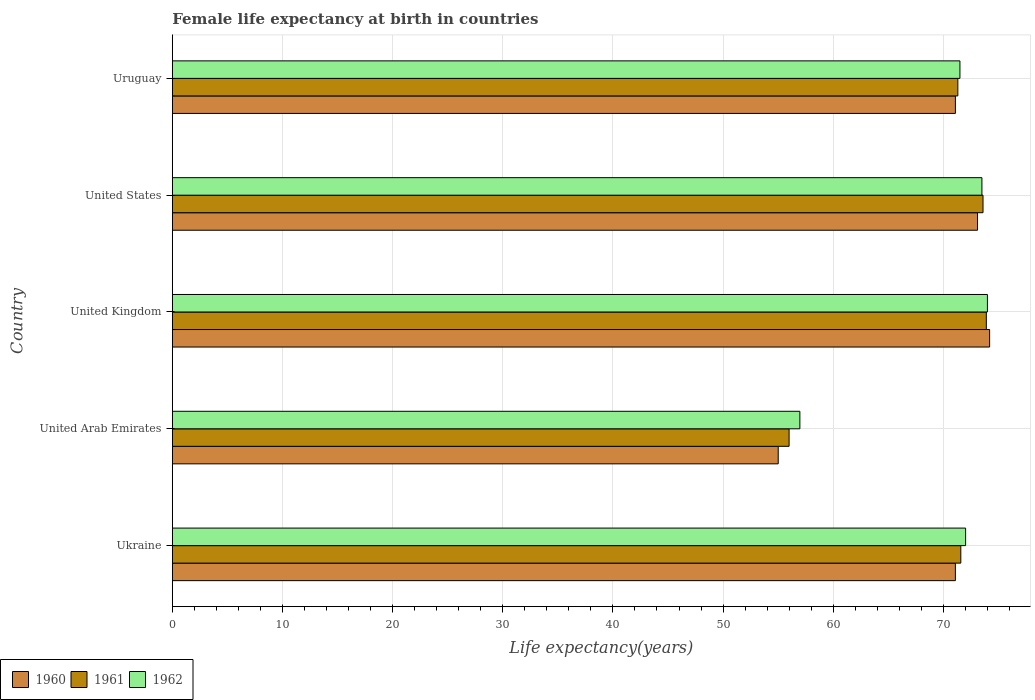How many different coloured bars are there?
Provide a succinct answer. 3. How many bars are there on the 2nd tick from the top?
Give a very brief answer. 3. How many bars are there on the 3rd tick from the bottom?
Make the answer very short. 3. What is the label of the 5th group of bars from the top?
Give a very brief answer. Ukraine. What is the female life expectancy at birth in 1962 in United States?
Keep it short and to the point. 73.5. Across all countries, what is the minimum female life expectancy at birth in 1960?
Keep it short and to the point. 55.01. In which country was the female life expectancy at birth in 1960 maximum?
Provide a short and direct response. United Kingdom. In which country was the female life expectancy at birth in 1960 minimum?
Provide a succinct answer. United Arab Emirates. What is the total female life expectancy at birth in 1960 in the graph?
Keep it short and to the point. 344.49. What is the difference between the female life expectancy at birth in 1962 in United Kingdom and the female life expectancy at birth in 1961 in Uruguay?
Your answer should be very brief. 2.69. What is the average female life expectancy at birth in 1961 per country?
Give a very brief answer. 69.28. What is the difference between the female life expectancy at birth in 1961 and female life expectancy at birth in 1960 in United Arab Emirates?
Offer a terse response. 0.99. What is the ratio of the female life expectancy at birth in 1961 in United Arab Emirates to that in United States?
Offer a terse response. 0.76. What is the difference between the highest and the lowest female life expectancy at birth in 1960?
Offer a terse response. 19.19. In how many countries, is the female life expectancy at birth in 1960 greater than the average female life expectancy at birth in 1960 taken over all countries?
Ensure brevity in your answer.  4. Is the sum of the female life expectancy at birth in 1960 in United Arab Emirates and United Kingdom greater than the maximum female life expectancy at birth in 1961 across all countries?
Make the answer very short. Yes. Are all the bars in the graph horizontal?
Make the answer very short. Yes. How many countries are there in the graph?
Offer a terse response. 5. What is the difference between two consecutive major ticks on the X-axis?
Offer a terse response. 10. What is the title of the graph?
Provide a short and direct response. Female life expectancy at birth in countries. Does "1998" appear as one of the legend labels in the graph?
Ensure brevity in your answer.  No. What is the label or title of the X-axis?
Your answer should be compact. Life expectancy(years). What is the label or title of the Y-axis?
Keep it short and to the point. Country. What is the Life expectancy(years) in 1960 in Ukraine?
Provide a succinct answer. 71.09. What is the Life expectancy(years) of 1961 in Ukraine?
Keep it short and to the point. 71.58. What is the Life expectancy(years) of 1962 in Ukraine?
Provide a succinct answer. 72.02. What is the Life expectancy(years) in 1960 in United Arab Emirates?
Your answer should be compact. 55.01. What is the Life expectancy(years) of 1961 in United Arab Emirates?
Offer a terse response. 55.99. What is the Life expectancy(years) of 1962 in United Arab Emirates?
Keep it short and to the point. 56.97. What is the Life expectancy(years) of 1960 in United Kingdom?
Provide a short and direct response. 74.2. What is the Life expectancy(years) in 1961 in United Kingdom?
Keep it short and to the point. 73.9. What is the Life expectancy(years) of 1962 in United Kingdom?
Give a very brief answer. 74. What is the Life expectancy(years) in 1960 in United States?
Make the answer very short. 73.1. What is the Life expectancy(years) in 1961 in United States?
Make the answer very short. 73.6. What is the Life expectancy(years) of 1962 in United States?
Offer a terse response. 73.5. What is the Life expectancy(years) of 1960 in Uruguay?
Offer a terse response. 71.09. What is the Life expectancy(years) of 1961 in Uruguay?
Your response must be concise. 71.31. What is the Life expectancy(years) of 1962 in Uruguay?
Your answer should be compact. 71.5. Across all countries, what is the maximum Life expectancy(years) of 1960?
Give a very brief answer. 74.2. Across all countries, what is the maximum Life expectancy(years) in 1961?
Provide a succinct answer. 73.9. Across all countries, what is the maximum Life expectancy(years) of 1962?
Provide a short and direct response. 74. Across all countries, what is the minimum Life expectancy(years) of 1960?
Keep it short and to the point. 55.01. Across all countries, what is the minimum Life expectancy(years) in 1961?
Provide a short and direct response. 55.99. Across all countries, what is the minimum Life expectancy(years) in 1962?
Your answer should be compact. 56.97. What is the total Life expectancy(years) in 1960 in the graph?
Your answer should be very brief. 344.49. What is the total Life expectancy(years) in 1961 in the graph?
Make the answer very short. 346.39. What is the total Life expectancy(years) of 1962 in the graph?
Provide a short and direct response. 348. What is the difference between the Life expectancy(years) of 1960 in Ukraine and that in United Arab Emirates?
Offer a terse response. 16.09. What is the difference between the Life expectancy(years) of 1961 in Ukraine and that in United Arab Emirates?
Ensure brevity in your answer.  15.59. What is the difference between the Life expectancy(years) in 1962 in Ukraine and that in United Arab Emirates?
Provide a short and direct response. 15.05. What is the difference between the Life expectancy(years) in 1960 in Ukraine and that in United Kingdom?
Your response must be concise. -3.11. What is the difference between the Life expectancy(years) of 1961 in Ukraine and that in United Kingdom?
Offer a terse response. -2.32. What is the difference between the Life expectancy(years) in 1962 in Ukraine and that in United Kingdom?
Offer a very short reply. -1.98. What is the difference between the Life expectancy(years) in 1960 in Ukraine and that in United States?
Your response must be concise. -2.01. What is the difference between the Life expectancy(years) in 1961 in Ukraine and that in United States?
Offer a terse response. -2.02. What is the difference between the Life expectancy(years) of 1962 in Ukraine and that in United States?
Give a very brief answer. -1.48. What is the difference between the Life expectancy(years) in 1960 in Ukraine and that in Uruguay?
Make the answer very short. -0. What is the difference between the Life expectancy(years) in 1961 in Ukraine and that in Uruguay?
Ensure brevity in your answer.  0.27. What is the difference between the Life expectancy(years) in 1962 in Ukraine and that in Uruguay?
Give a very brief answer. 0.52. What is the difference between the Life expectancy(years) in 1960 in United Arab Emirates and that in United Kingdom?
Your answer should be very brief. -19.19. What is the difference between the Life expectancy(years) in 1961 in United Arab Emirates and that in United Kingdom?
Ensure brevity in your answer.  -17.91. What is the difference between the Life expectancy(years) in 1962 in United Arab Emirates and that in United Kingdom?
Give a very brief answer. -17.03. What is the difference between the Life expectancy(years) in 1960 in United Arab Emirates and that in United States?
Keep it short and to the point. -18.09. What is the difference between the Life expectancy(years) in 1961 in United Arab Emirates and that in United States?
Make the answer very short. -17.61. What is the difference between the Life expectancy(years) of 1962 in United Arab Emirates and that in United States?
Your response must be concise. -16.53. What is the difference between the Life expectancy(years) of 1960 in United Arab Emirates and that in Uruguay?
Offer a very short reply. -16.09. What is the difference between the Life expectancy(years) of 1961 in United Arab Emirates and that in Uruguay?
Your answer should be compact. -15.32. What is the difference between the Life expectancy(years) of 1962 in United Arab Emirates and that in Uruguay?
Provide a succinct answer. -14.53. What is the difference between the Life expectancy(years) in 1960 in United Kingdom and that in United States?
Your response must be concise. 1.1. What is the difference between the Life expectancy(years) in 1960 in United Kingdom and that in Uruguay?
Your answer should be compact. 3.11. What is the difference between the Life expectancy(years) of 1961 in United Kingdom and that in Uruguay?
Your answer should be very brief. 2.59. What is the difference between the Life expectancy(years) in 1962 in United Kingdom and that in Uruguay?
Your answer should be compact. 2.5. What is the difference between the Life expectancy(years) in 1960 in United States and that in Uruguay?
Your answer should be very brief. 2.01. What is the difference between the Life expectancy(years) of 1961 in United States and that in Uruguay?
Make the answer very short. 2.29. What is the difference between the Life expectancy(years) in 1962 in United States and that in Uruguay?
Keep it short and to the point. 2. What is the difference between the Life expectancy(years) of 1960 in Ukraine and the Life expectancy(years) of 1961 in United Arab Emirates?
Keep it short and to the point. 15.1. What is the difference between the Life expectancy(years) in 1960 in Ukraine and the Life expectancy(years) in 1962 in United Arab Emirates?
Give a very brief answer. 14.12. What is the difference between the Life expectancy(years) in 1961 in Ukraine and the Life expectancy(years) in 1962 in United Arab Emirates?
Provide a succinct answer. 14.61. What is the difference between the Life expectancy(years) of 1960 in Ukraine and the Life expectancy(years) of 1961 in United Kingdom?
Keep it short and to the point. -2.81. What is the difference between the Life expectancy(years) in 1960 in Ukraine and the Life expectancy(years) in 1962 in United Kingdom?
Provide a succinct answer. -2.91. What is the difference between the Life expectancy(years) of 1961 in Ukraine and the Life expectancy(years) of 1962 in United Kingdom?
Offer a very short reply. -2.42. What is the difference between the Life expectancy(years) of 1960 in Ukraine and the Life expectancy(years) of 1961 in United States?
Give a very brief answer. -2.51. What is the difference between the Life expectancy(years) of 1960 in Ukraine and the Life expectancy(years) of 1962 in United States?
Offer a very short reply. -2.41. What is the difference between the Life expectancy(years) of 1961 in Ukraine and the Life expectancy(years) of 1962 in United States?
Your answer should be compact. -1.92. What is the difference between the Life expectancy(years) of 1960 in Ukraine and the Life expectancy(years) of 1961 in Uruguay?
Provide a short and direct response. -0.22. What is the difference between the Life expectancy(years) of 1960 in Ukraine and the Life expectancy(years) of 1962 in Uruguay?
Ensure brevity in your answer.  -0.41. What is the difference between the Life expectancy(years) in 1960 in United Arab Emirates and the Life expectancy(years) in 1961 in United Kingdom?
Ensure brevity in your answer.  -18.89. What is the difference between the Life expectancy(years) in 1960 in United Arab Emirates and the Life expectancy(years) in 1962 in United Kingdom?
Offer a terse response. -18.99. What is the difference between the Life expectancy(years) of 1961 in United Arab Emirates and the Life expectancy(years) of 1962 in United Kingdom?
Make the answer very short. -18.01. What is the difference between the Life expectancy(years) in 1960 in United Arab Emirates and the Life expectancy(years) in 1961 in United States?
Offer a very short reply. -18.59. What is the difference between the Life expectancy(years) in 1960 in United Arab Emirates and the Life expectancy(years) in 1962 in United States?
Your answer should be compact. -18.49. What is the difference between the Life expectancy(years) in 1961 in United Arab Emirates and the Life expectancy(years) in 1962 in United States?
Ensure brevity in your answer.  -17.51. What is the difference between the Life expectancy(years) of 1960 in United Arab Emirates and the Life expectancy(years) of 1961 in Uruguay?
Give a very brief answer. -16.31. What is the difference between the Life expectancy(years) of 1960 in United Arab Emirates and the Life expectancy(years) of 1962 in Uruguay?
Provide a short and direct response. -16.5. What is the difference between the Life expectancy(years) of 1961 in United Arab Emirates and the Life expectancy(years) of 1962 in Uruguay?
Provide a succinct answer. -15.51. What is the difference between the Life expectancy(years) in 1960 in United Kingdom and the Life expectancy(years) in 1961 in United States?
Give a very brief answer. 0.6. What is the difference between the Life expectancy(years) of 1960 in United Kingdom and the Life expectancy(years) of 1962 in United States?
Your response must be concise. 0.7. What is the difference between the Life expectancy(years) in 1960 in United Kingdom and the Life expectancy(years) in 1961 in Uruguay?
Your response must be concise. 2.89. What is the difference between the Life expectancy(years) in 1960 in United Kingdom and the Life expectancy(years) in 1962 in Uruguay?
Your answer should be compact. 2.7. What is the difference between the Life expectancy(years) in 1961 in United Kingdom and the Life expectancy(years) in 1962 in Uruguay?
Your answer should be very brief. 2.4. What is the difference between the Life expectancy(years) in 1960 in United States and the Life expectancy(years) in 1961 in Uruguay?
Keep it short and to the point. 1.79. What is the difference between the Life expectancy(years) of 1960 in United States and the Life expectancy(years) of 1962 in Uruguay?
Offer a very short reply. 1.6. What is the difference between the Life expectancy(years) of 1961 in United States and the Life expectancy(years) of 1962 in Uruguay?
Your response must be concise. 2.1. What is the average Life expectancy(years) in 1960 per country?
Provide a succinct answer. 68.9. What is the average Life expectancy(years) in 1961 per country?
Provide a short and direct response. 69.28. What is the average Life expectancy(years) in 1962 per country?
Your answer should be very brief. 69.6. What is the difference between the Life expectancy(years) of 1960 and Life expectancy(years) of 1961 in Ukraine?
Give a very brief answer. -0.49. What is the difference between the Life expectancy(years) of 1960 and Life expectancy(years) of 1962 in Ukraine?
Ensure brevity in your answer.  -0.93. What is the difference between the Life expectancy(years) in 1961 and Life expectancy(years) in 1962 in Ukraine?
Your answer should be compact. -0.43. What is the difference between the Life expectancy(years) in 1960 and Life expectancy(years) in 1961 in United Arab Emirates?
Keep it short and to the point. -0.99. What is the difference between the Life expectancy(years) of 1960 and Life expectancy(years) of 1962 in United Arab Emirates?
Keep it short and to the point. -1.97. What is the difference between the Life expectancy(years) in 1961 and Life expectancy(years) in 1962 in United Arab Emirates?
Offer a terse response. -0.98. What is the difference between the Life expectancy(years) of 1960 and Life expectancy(years) of 1961 in United Kingdom?
Your response must be concise. 0.3. What is the difference between the Life expectancy(years) in 1960 and Life expectancy(years) in 1962 in United Kingdom?
Your answer should be compact. 0.2. What is the difference between the Life expectancy(years) of 1961 and Life expectancy(years) of 1962 in United Kingdom?
Your answer should be compact. -0.1. What is the difference between the Life expectancy(years) in 1960 and Life expectancy(years) in 1961 in United States?
Give a very brief answer. -0.5. What is the difference between the Life expectancy(years) in 1960 and Life expectancy(years) in 1961 in Uruguay?
Provide a succinct answer. -0.22. What is the difference between the Life expectancy(years) of 1960 and Life expectancy(years) of 1962 in Uruguay?
Offer a terse response. -0.41. What is the difference between the Life expectancy(years) in 1961 and Life expectancy(years) in 1962 in Uruguay?
Give a very brief answer. -0.19. What is the ratio of the Life expectancy(years) in 1960 in Ukraine to that in United Arab Emirates?
Make the answer very short. 1.29. What is the ratio of the Life expectancy(years) in 1961 in Ukraine to that in United Arab Emirates?
Your answer should be compact. 1.28. What is the ratio of the Life expectancy(years) of 1962 in Ukraine to that in United Arab Emirates?
Provide a short and direct response. 1.26. What is the ratio of the Life expectancy(years) in 1960 in Ukraine to that in United Kingdom?
Give a very brief answer. 0.96. What is the ratio of the Life expectancy(years) in 1961 in Ukraine to that in United Kingdom?
Offer a very short reply. 0.97. What is the ratio of the Life expectancy(years) in 1962 in Ukraine to that in United Kingdom?
Keep it short and to the point. 0.97. What is the ratio of the Life expectancy(years) in 1960 in Ukraine to that in United States?
Keep it short and to the point. 0.97. What is the ratio of the Life expectancy(years) in 1961 in Ukraine to that in United States?
Make the answer very short. 0.97. What is the ratio of the Life expectancy(years) in 1962 in Ukraine to that in United States?
Provide a succinct answer. 0.98. What is the ratio of the Life expectancy(years) of 1960 in Ukraine to that in Uruguay?
Give a very brief answer. 1. What is the ratio of the Life expectancy(years) of 1960 in United Arab Emirates to that in United Kingdom?
Your response must be concise. 0.74. What is the ratio of the Life expectancy(years) in 1961 in United Arab Emirates to that in United Kingdom?
Your answer should be very brief. 0.76. What is the ratio of the Life expectancy(years) of 1962 in United Arab Emirates to that in United Kingdom?
Offer a terse response. 0.77. What is the ratio of the Life expectancy(years) in 1960 in United Arab Emirates to that in United States?
Keep it short and to the point. 0.75. What is the ratio of the Life expectancy(years) of 1961 in United Arab Emirates to that in United States?
Provide a short and direct response. 0.76. What is the ratio of the Life expectancy(years) of 1962 in United Arab Emirates to that in United States?
Offer a very short reply. 0.78. What is the ratio of the Life expectancy(years) of 1960 in United Arab Emirates to that in Uruguay?
Provide a short and direct response. 0.77. What is the ratio of the Life expectancy(years) in 1961 in United Arab Emirates to that in Uruguay?
Give a very brief answer. 0.79. What is the ratio of the Life expectancy(years) in 1962 in United Arab Emirates to that in Uruguay?
Offer a very short reply. 0.8. What is the ratio of the Life expectancy(years) in 1961 in United Kingdom to that in United States?
Provide a short and direct response. 1. What is the ratio of the Life expectancy(years) of 1962 in United Kingdom to that in United States?
Ensure brevity in your answer.  1.01. What is the ratio of the Life expectancy(years) of 1960 in United Kingdom to that in Uruguay?
Give a very brief answer. 1.04. What is the ratio of the Life expectancy(years) in 1961 in United Kingdom to that in Uruguay?
Offer a terse response. 1.04. What is the ratio of the Life expectancy(years) of 1962 in United Kingdom to that in Uruguay?
Make the answer very short. 1.03. What is the ratio of the Life expectancy(years) of 1960 in United States to that in Uruguay?
Make the answer very short. 1.03. What is the ratio of the Life expectancy(years) in 1961 in United States to that in Uruguay?
Give a very brief answer. 1.03. What is the ratio of the Life expectancy(years) of 1962 in United States to that in Uruguay?
Ensure brevity in your answer.  1.03. What is the difference between the highest and the second highest Life expectancy(years) in 1960?
Provide a succinct answer. 1.1. What is the difference between the highest and the lowest Life expectancy(years) in 1960?
Your answer should be compact. 19.19. What is the difference between the highest and the lowest Life expectancy(years) in 1961?
Your answer should be compact. 17.91. What is the difference between the highest and the lowest Life expectancy(years) in 1962?
Offer a terse response. 17.03. 